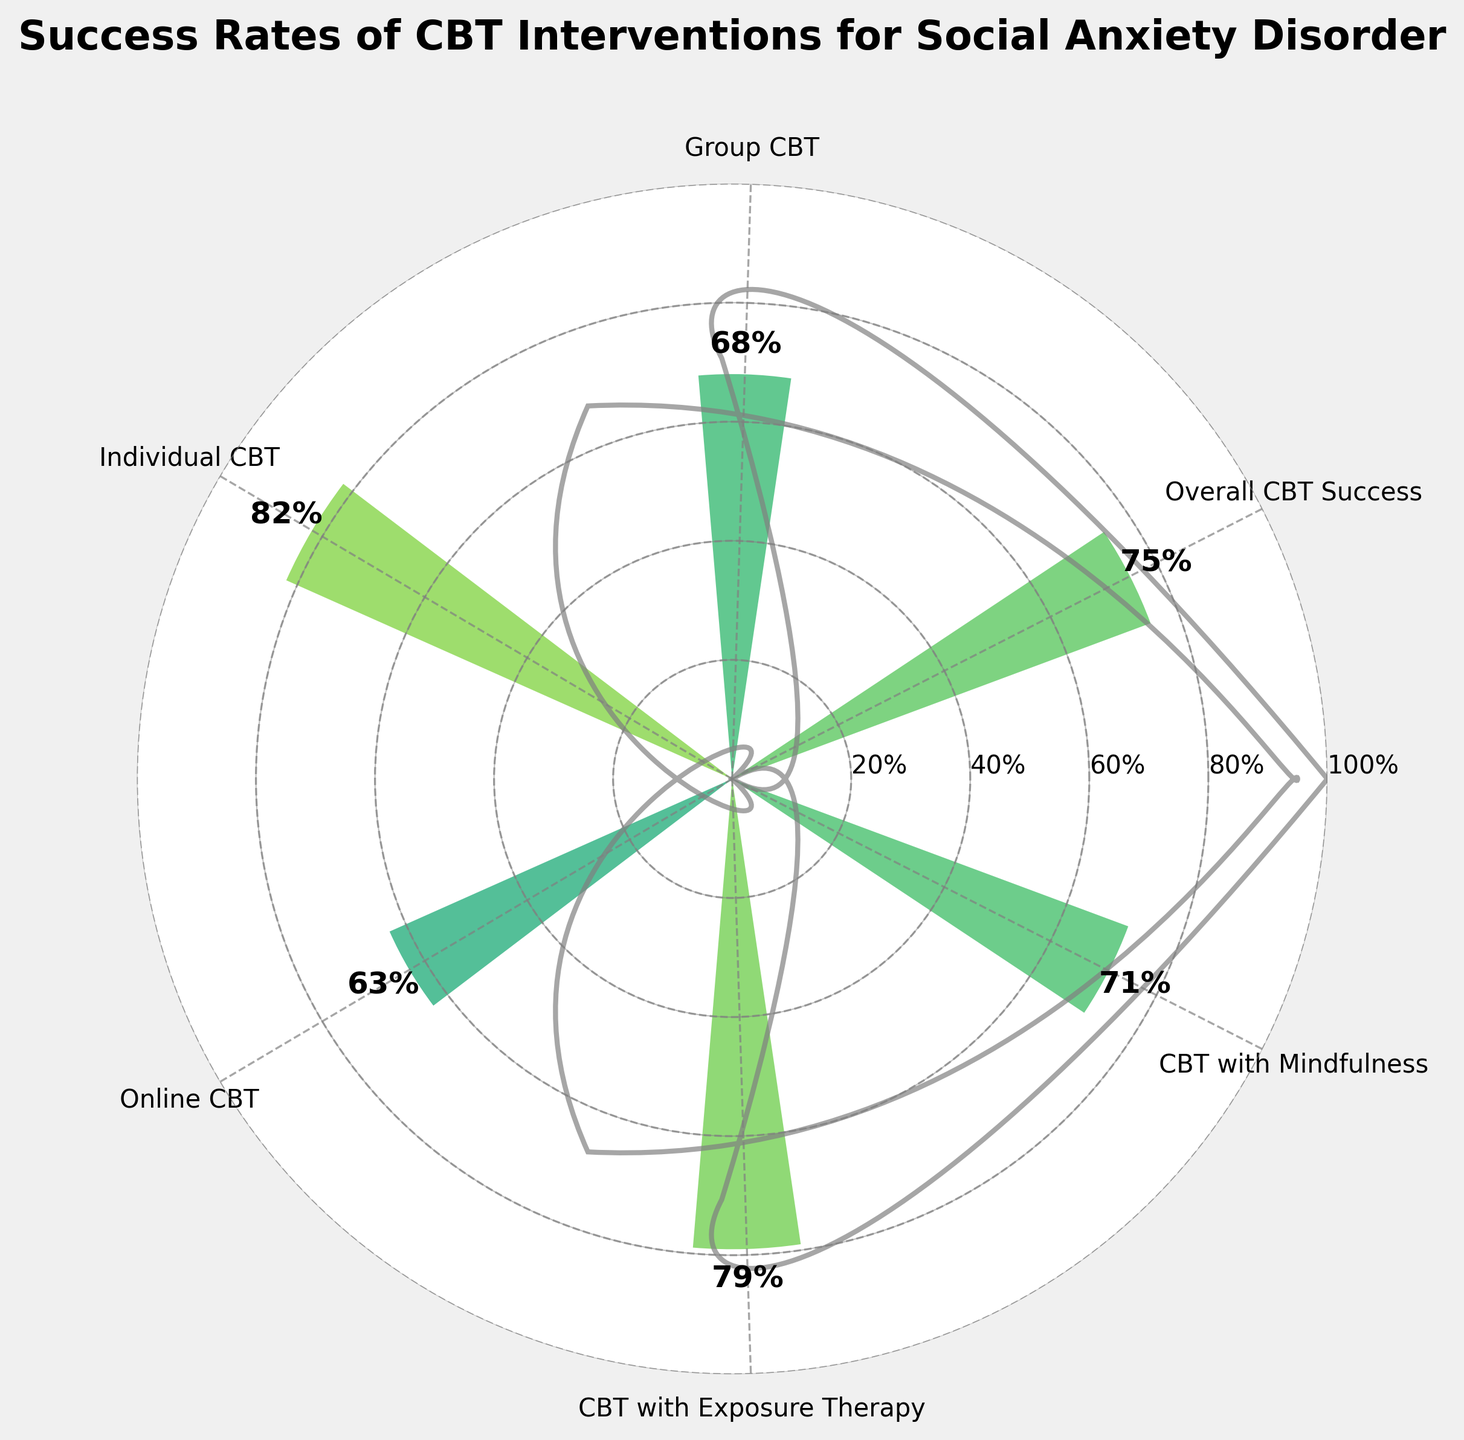What is the title of the figure? The title of the figure is shown at the top and it summarizes the information presented. This helps provide context for what the data represents.
Answer: Success Rates of CBT Interventions for Social Anxiety Disorder How many different CBT interventions are shown in the figure? Count the number of bars or labels on the outer edge of the plot, each representing a different CBT intervention.
Answer: 6 Which CBT intervention has the highest success rate? Identify the tallest bar and read its label to determine the highest success rate among the interventions.
Answer: Individual CBT What is the success rate of Group CBT? Locate the bar labeled "Group CBT" and read the value indicated by the bar and its label.
Answer: 68% Which CBT intervention has a success rate lower than 65%? Look for bars that have a height representing a success rate lower than 65%.
Answer: Online CBT Calculate the average success rate of all shown CBT interventions. Sum all the success rates given in the figure and then divide by the number of interventions. (75 + 68 + 82 + 63 + 79 + 71)/6
Answer: 73% Compare the success rate of CBT with Exposure Therapy to CBT with Mindfulness. Which one is higher and by how much? Note the values for CBT with Exposure Therapy and CBT with Mindfulness, then subtract the smaller value from the larger value to find the difference.
Answer: CBT with Exposure Therapy is higher by 8% Is the success rate of the Overall CBT Success closer to the highest or the lowest success rate among the interventions? Identify the highest (82%) and lowest (63%) success rates, then determine the distance from 75% (Overall CBT Success) to these values.
Answer: Closer to the highest Which two CBT interventions have success rates closest to each other? Compare the success rates and find the pair with the smallest numerical difference.
Answer: CBT with Mindfulness and Group CBT What visual elements are used to represent the radial gauge-like elements in the chart? Identify and describe the visual elements in the shape of concentric circles and wedges originating from the center of the plot.
Answer: Circles and wedges 